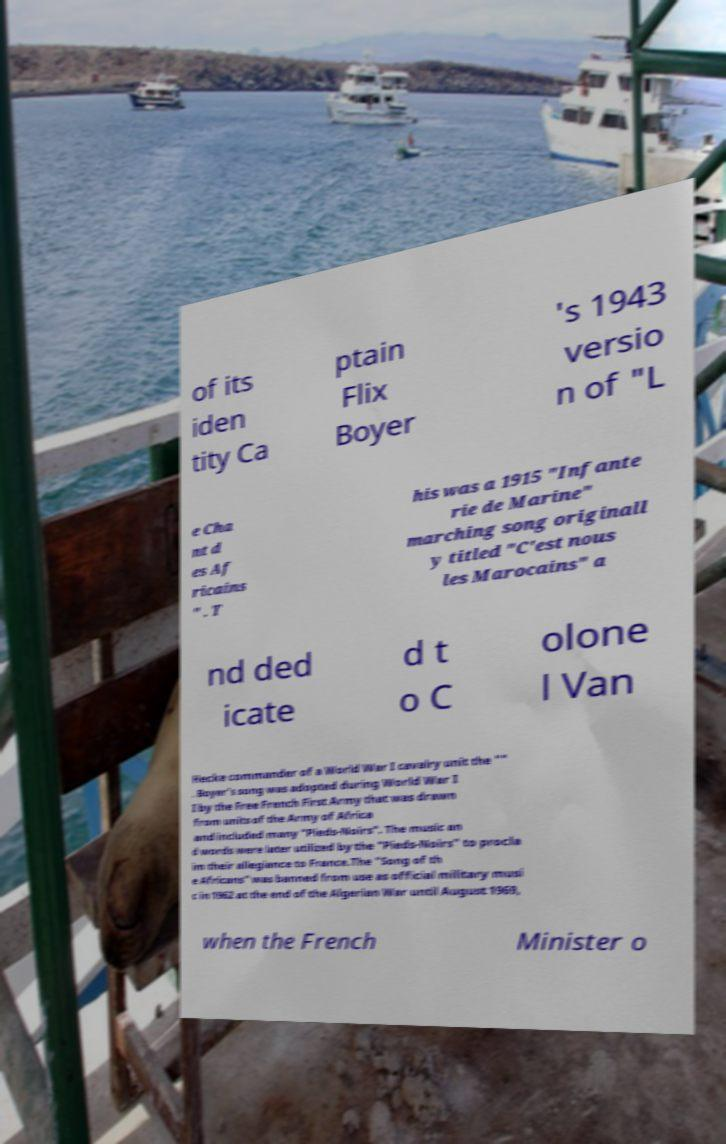Please read and relay the text visible in this image. What does it say? of its iden tity Ca ptain Flix Boyer 's 1943 versio n of "L e Cha nt d es Af ricains " . T his was a 1915 "Infante rie de Marine" marching song originall y titled "C'est nous les Marocains" a nd ded icate d t o C olone l Van Hecke commander of a World War I cavalry unit the "" . Boyer's song was adopted during World War I I by the Free French First Army that was drawn from units of the Army of Africa and included many "Pieds-Noirs". The music an d words were later utilized by the "Pieds-Noirs" to procla im their allegiance to France.The "Song of th e Africans" was banned from use as official military musi c in 1962 at the end of the Algerian War until August 1969, when the French Minister o 